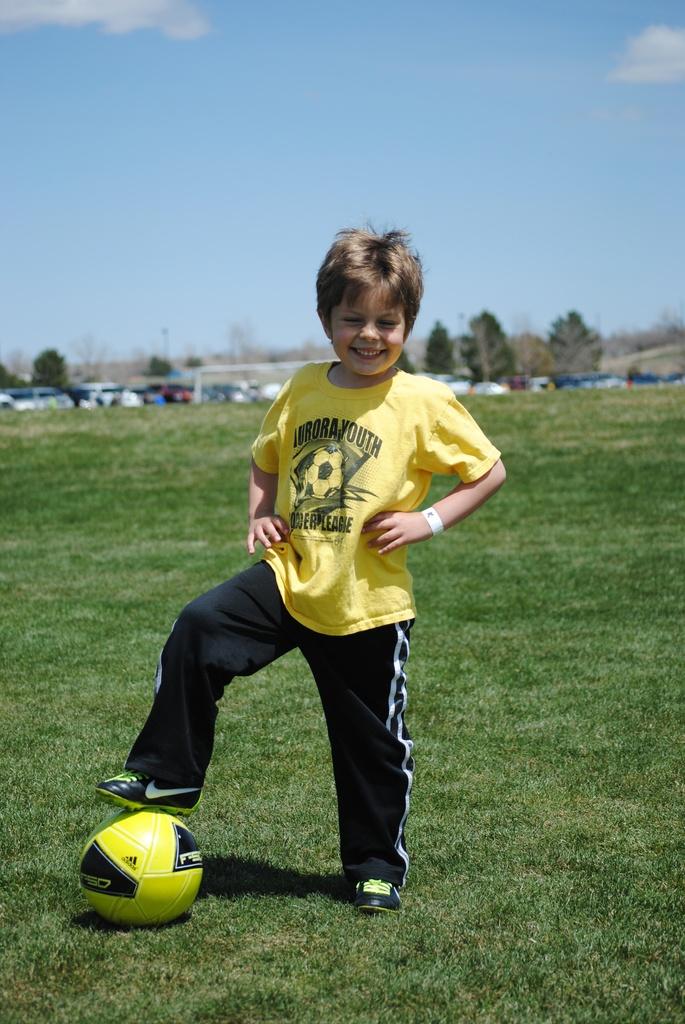What is the name of the league this child is with?
Ensure brevity in your answer.  Aurora youth. What brand is the soccer ball?
Make the answer very short. Adidas. 